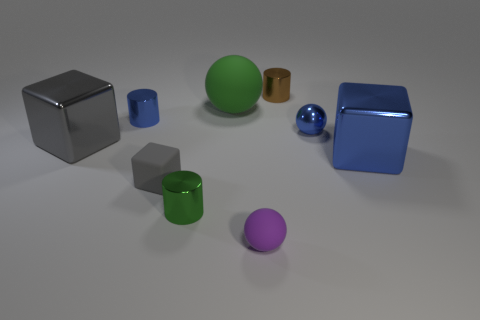Is the tiny green metal object the same shape as the large blue thing?
Your answer should be compact. No. What is the size of the object behind the green thing that is behind the large gray shiny block?
Your response must be concise. Small. Is there a blue cube that has the same size as the purple matte sphere?
Offer a very short reply. No. There is a blue ball in front of the big matte thing; does it have the same size as the cylinder that is left of the tiny gray thing?
Ensure brevity in your answer.  Yes. What is the shape of the small matte object on the right side of the tiny cylinder that is in front of the small gray matte thing?
Keep it short and to the point. Sphere. How many tiny blue metal things are to the left of the gray rubber thing?
Provide a succinct answer. 1. There is a ball that is the same material as the brown thing; what color is it?
Your answer should be very brief. Blue. There is a rubber cube; does it have the same size as the cube behind the blue cube?
Your answer should be very brief. No. There is a green thing in front of the large shiny block on the right side of the big metal block that is to the left of the brown shiny object; what size is it?
Make the answer very short. Small. What number of rubber objects are yellow cylinders or small blue objects?
Your response must be concise. 0. 